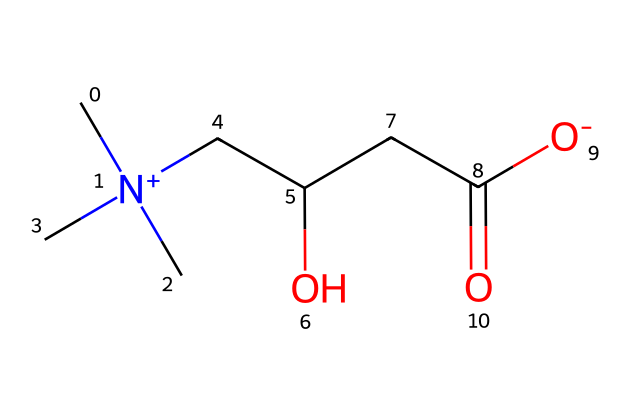What is the main functional group present in L-carnitine? The structure shows a hydroxyl group (–OH) and a carboxylate group (–COO–). The hydroxyl group is the main functional group since it is directly attached to the carbon chain as –CH(OH)–.
Answer: hydroxyl group How many chiral centers are in L-carnitine? To determine the number of chiral centers, we identify carbon atoms bonded to four different substituents. In L-carnitine, the carbon next to the hydroxyl group is the only chiral center.
Answer: one What is the total number of nitrogen atoms in L-carnitine? The SMILES representation indicates that there is one nitrogen atom present in the structure, as seen in the quaternary ammonium group.
Answer: one Does L-carnitine contain any double bonds? The structure features a carboxylate carbon double bonded to an oxygen (–C(=O)O–) and does not contain carbon-to-carbon double bonds.
Answer: yes What is the net charge of L-carnitine at physiological pH? The nitrogen in L-carnitine is positively charged due to the quaternary ammonium, and the carboxylate group has a negative charge, resulting in a zero net charge overall at physiological pH.
Answer: zero What type of compound is L-carnitine? L-carnitine is classified as an amino acid due to the presence of both an amino (–NH) and a carboxylic acid group (–COOH) in its structure.
Answer: amino acid What role does the hydroxyl group play in L-carnitine? The hydroxyl group contributes to the solubility of L-carnitine in water and plays a significant role in its biological function, such as engaging in hydrogen bonding.
Answer: solubility 